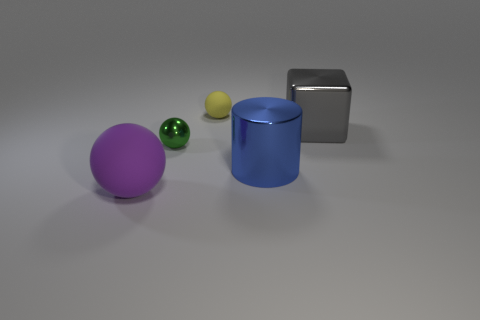Subtract all matte balls. How many balls are left? 1 Add 5 blue metallic objects. How many objects exist? 10 Subtract 1 purple spheres. How many objects are left? 4 Subtract all cylinders. How many objects are left? 4 Subtract all big yellow matte cylinders. Subtract all large blue metal cylinders. How many objects are left? 4 Add 4 yellow balls. How many yellow balls are left? 5 Add 1 blue objects. How many blue objects exist? 2 